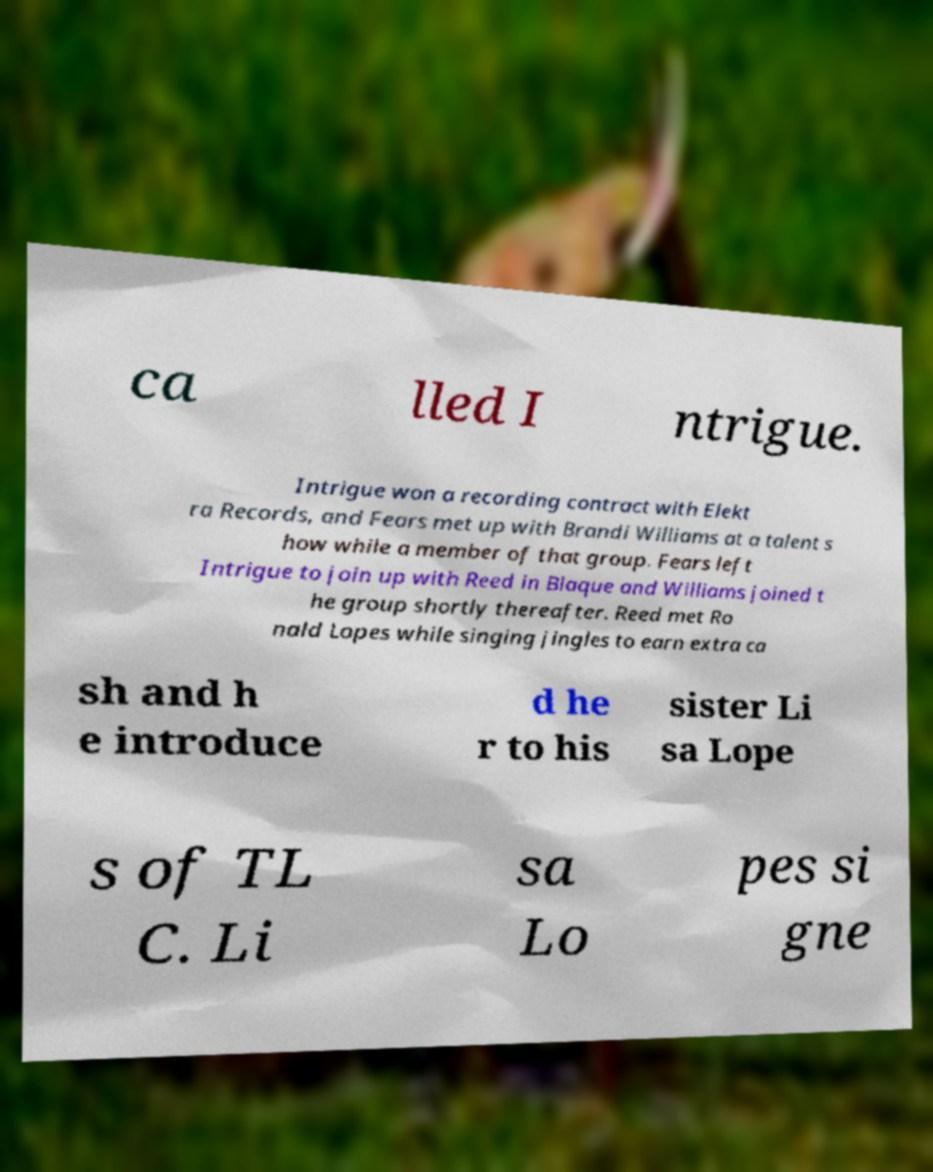What messages or text are displayed in this image? I need them in a readable, typed format. ca lled I ntrigue. Intrigue won a recording contract with Elekt ra Records, and Fears met up with Brandi Williams at a talent s how while a member of that group. Fears left Intrigue to join up with Reed in Blaque and Williams joined t he group shortly thereafter. Reed met Ro nald Lopes while singing jingles to earn extra ca sh and h e introduce d he r to his sister Li sa Lope s of TL C. Li sa Lo pes si gne 